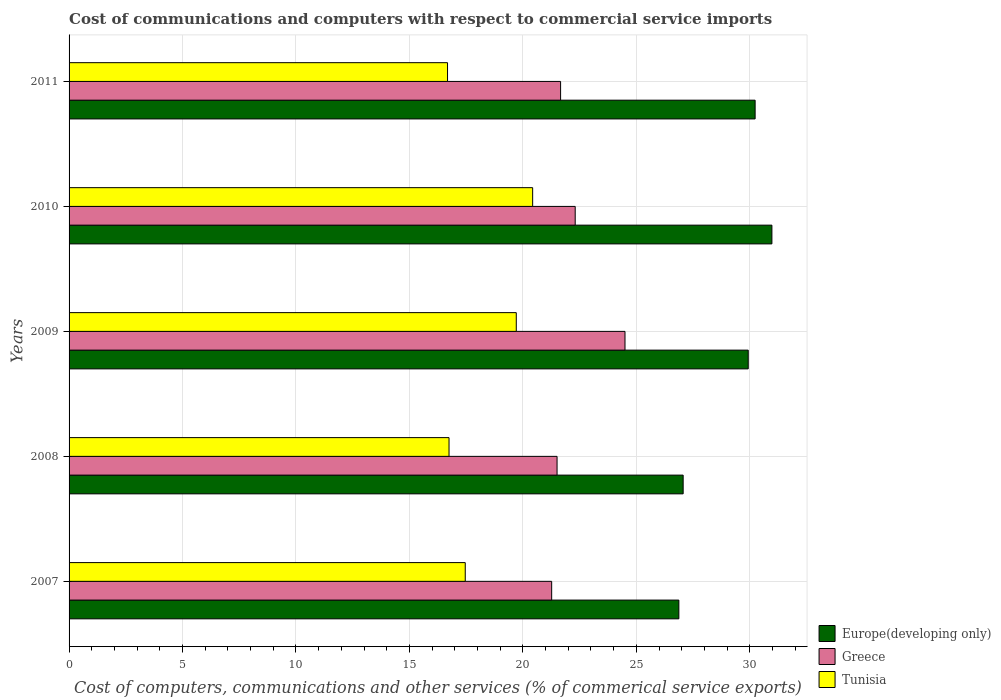How many different coloured bars are there?
Offer a terse response. 3. How many groups of bars are there?
Give a very brief answer. 5. How many bars are there on the 4th tick from the bottom?
Provide a succinct answer. 3. In how many cases, is the number of bars for a given year not equal to the number of legend labels?
Make the answer very short. 0. What is the cost of communications and computers in Tunisia in 2008?
Give a very brief answer. 16.75. Across all years, what is the maximum cost of communications and computers in Europe(developing only)?
Provide a short and direct response. 30.98. Across all years, what is the minimum cost of communications and computers in Tunisia?
Ensure brevity in your answer.  16.68. In which year was the cost of communications and computers in Europe(developing only) maximum?
Provide a succinct answer. 2010. What is the total cost of communications and computers in Greece in the graph?
Offer a very short reply. 111.25. What is the difference between the cost of communications and computers in Europe(developing only) in 2007 and that in 2011?
Offer a very short reply. -3.36. What is the difference between the cost of communications and computers in Greece in 2010 and the cost of communications and computers in Europe(developing only) in 2007?
Ensure brevity in your answer.  -4.57. What is the average cost of communications and computers in Europe(developing only) per year?
Your answer should be very brief. 29.02. In the year 2007, what is the difference between the cost of communications and computers in Greece and cost of communications and computers in Tunisia?
Your response must be concise. 3.81. In how many years, is the cost of communications and computers in Europe(developing only) greater than 3 %?
Offer a terse response. 5. What is the ratio of the cost of communications and computers in Greece in 2008 to that in 2009?
Your response must be concise. 0.88. What is the difference between the highest and the second highest cost of communications and computers in Europe(developing only)?
Keep it short and to the point. 0.74. What is the difference between the highest and the lowest cost of communications and computers in Tunisia?
Keep it short and to the point. 3.75. What does the 3rd bar from the bottom in 2007 represents?
Offer a very short reply. Tunisia. Are all the bars in the graph horizontal?
Provide a succinct answer. Yes. Are the values on the major ticks of X-axis written in scientific E-notation?
Keep it short and to the point. No. Does the graph contain any zero values?
Give a very brief answer. No. Does the graph contain grids?
Provide a succinct answer. Yes. Where does the legend appear in the graph?
Provide a short and direct response. Bottom right. How many legend labels are there?
Your answer should be very brief. 3. What is the title of the graph?
Your answer should be compact. Cost of communications and computers with respect to commercial service imports. What is the label or title of the X-axis?
Provide a short and direct response. Cost of computers, communications and other services (% of commerical service exports). What is the label or title of the Y-axis?
Provide a succinct answer. Years. What is the Cost of computers, communications and other services (% of commerical service exports) of Europe(developing only) in 2007?
Your answer should be compact. 26.88. What is the Cost of computers, communications and other services (% of commerical service exports) of Greece in 2007?
Offer a very short reply. 21.27. What is the Cost of computers, communications and other services (% of commerical service exports) in Tunisia in 2007?
Provide a succinct answer. 17.46. What is the Cost of computers, communications and other services (% of commerical service exports) of Europe(developing only) in 2008?
Your answer should be very brief. 27.07. What is the Cost of computers, communications and other services (% of commerical service exports) in Greece in 2008?
Give a very brief answer. 21.51. What is the Cost of computers, communications and other services (% of commerical service exports) in Tunisia in 2008?
Your answer should be very brief. 16.75. What is the Cost of computers, communications and other services (% of commerical service exports) of Europe(developing only) in 2009?
Keep it short and to the point. 29.93. What is the Cost of computers, communications and other services (% of commerical service exports) in Greece in 2009?
Make the answer very short. 24.5. What is the Cost of computers, communications and other services (% of commerical service exports) in Tunisia in 2009?
Your answer should be very brief. 19.71. What is the Cost of computers, communications and other services (% of commerical service exports) in Europe(developing only) in 2010?
Make the answer very short. 30.98. What is the Cost of computers, communications and other services (% of commerical service exports) in Greece in 2010?
Your answer should be very brief. 22.31. What is the Cost of computers, communications and other services (% of commerical service exports) of Tunisia in 2010?
Provide a short and direct response. 20.43. What is the Cost of computers, communications and other services (% of commerical service exports) in Europe(developing only) in 2011?
Your answer should be compact. 30.24. What is the Cost of computers, communications and other services (% of commerical service exports) in Greece in 2011?
Your answer should be very brief. 21.66. What is the Cost of computers, communications and other services (% of commerical service exports) in Tunisia in 2011?
Your answer should be very brief. 16.68. Across all years, what is the maximum Cost of computers, communications and other services (% of commerical service exports) of Europe(developing only)?
Offer a very short reply. 30.98. Across all years, what is the maximum Cost of computers, communications and other services (% of commerical service exports) in Greece?
Ensure brevity in your answer.  24.5. Across all years, what is the maximum Cost of computers, communications and other services (% of commerical service exports) of Tunisia?
Make the answer very short. 20.43. Across all years, what is the minimum Cost of computers, communications and other services (% of commerical service exports) in Europe(developing only)?
Ensure brevity in your answer.  26.88. Across all years, what is the minimum Cost of computers, communications and other services (% of commerical service exports) of Greece?
Offer a terse response. 21.27. Across all years, what is the minimum Cost of computers, communications and other services (% of commerical service exports) in Tunisia?
Keep it short and to the point. 16.68. What is the total Cost of computers, communications and other services (% of commerical service exports) of Europe(developing only) in the graph?
Provide a succinct answer. 145.09. What is the total Cost of computers, communications and other services (% of commerical service exports) in Greece in the graph?
Your response must be concise. 111.25. What is the total Cost of computers, communications and other services (% of commerical service exports) of Tunisia in the graph?
Your answer should be compact. 91.03. What is the difference between the Cost of computers, communications and other services (% of commerical service exports) of Europe(developing only) in 2007 and that in 2008?
Provide a short and direct response. -0.19. What is the difference between the Cost of computers, communications and other services (% of commerical service exports) in Greece in 2007 and that in 2008?
Make the answer very short. -0.24. What is the difference between the Cost of computers, communications and other services (% of commerical service exports) of Tunisia in 2007 and that in 2008?
Your response must be concise. 0.71. What is the difference between the Cost of computers, communications and other services (% of commerical service exports) in Europe(developing only) in 2007 and that in 2009?
Provide a short and direct response. -3.06. What is the difference between the Cost of computers, communications and other services (% of commerical service exports) in Greece in 2007 and that in 2009?
Your answer should be very brief. -3.23. What is the difference between the Cost of computers, communications and other services (% of commerical service exports) of Tunisia in 2007 and that in 2009?
Keep it short and to the point. -2.25. What is the difference between the Cost of computers, communications and other services (% of commerical service exports) in Europe(developing only) in 2007 and that in 2010?
Provide a succinct answer. -4.1. What is the difference between the Cost of computers, communications and other services (% of commerical service exports) of Greece in 2007 and that in 2010?
Provide a succinct answer. -1.04. What is the difference between the Cost of computers, communications and other services (% of commerical service exports) of Tunisia in 2007 and that in 2010?
Keep it short and to the point. -2.97. What is the difference between the Cost of computers, communications and other services (% of commerical service exports) in Europe(developing only) in 2007 and that in 2011?
Provide a succinct answer. -3.36. What is the difference between the Cost of computers, communications and other services (% of commerical service exports) of Greece in 2007 and that in 2011?
Your answer should be very brief. -0.39. What is the difference between the Cost of computers, communications and other services (% of commerical service exports) of Tunisia in 2007 and that in 2011?
Offer a very short reply. 0.78. What is the difference between the Cost of computers, communications and other services (% of commerical service exports) of Europe(developing only) in 2008 and that in 2009?
Your answer should be very brief. -2.87. What is the difference between the Cost of computers, communications and other services (% of commerical service exports) in Greece in 2008 and that in 2009?
Your answer should be very brief. -2.99. What is the difference between the Cost of computers, communications and other services (% of commerical service exports) of Tunisia in 2008 and that in 2009?
Your response must be concise. -2.96. What is the difference between the Cost of computers, communications and other services (% of commerical service exports) of Europe(developing only) in 2008 and that in 2010?
Give a very brief answer. -3.91. What is the difference between the Cost of computers, communications and other services (% of commerical service exports) in Greece in 2008 and that in 2010?
Ensure brevity in your answer.  -0.8. What is the difference between the Cost of computers, communications and other services (% of commerical service exports) of Tunisia in 2008 and that in 2010?
Provide a succinct answer. -3.69. What is the difference between the Cost of computers, communications and other services (% of commerical service exports) in Europe(developing only) in 2008 and that in 2011?
Your response must be concise. -3.17. What is the difference between the Cost of computers, communications and other services (% of commerical service exports) of Greece in 2008 and that in 2011?
Your answer should be compact. -0.16. What is the difference between the Cost of computers, communications and other services (% of commerical service exports) in Tunisia in 2008 and that in 2011?
Provide a succinct answer. 0.07. What is the difference between the Cost of computers, communications and other services (% of commerical service exports) of Europe(developing only) in 2009 and that in 2010?
Offer a very short reply. -1.04. What is the difference between the Cost of computers, communications and other services (% of commerical service exports) in Greece in 2009 and that in 2010?
Your answer should be compact. 2.19. What is the difference between the Cost of computers, communications and other services (% of commerical service exports) in Tunisia in 2009 and that in 2010?
Your response must be concise. -0.72. What is the difference between the Cost of computers, communications and other services (% of commerical service exports) in Europe(developing only) in 2009 and that in 2011?
Offer a very short reply. -0.3. What is the difference between the Cost of computers, communications and other services (% of commerical service exports) of Greece in 2009 and that in 2011?
Ensure brevity in your answer.  2.84. What is the difference between the Cost of computers, communications and other services (% of commerical service exports) of Tunisia in 2009 and that in 2011?
Offer a terse response. 3.03. What is the difference between the Cost of computers, communications and other services (% of commerical service exports) in Europe(developing only) in 2010 and that in 2011?
Keep it short and to the point. 0.74. What is the difference between the Cost of computers, communications and other services (% of commerical service exports) of Greece in 2010 and that in 2011?
Provide a short and direct response. 0.64. What is the difference between the Cost of computers, communications and other services (% of commerical service exports) of Tunisia in 2010 and that in 2011?
Keep it short and to the point. 3.75. What is the difference between the Cost of computers, communications and other services (% of commerical service exports) of Europe(developing only) in 2007 and the Cost of computers, communications and other services (% of commerical service exports) of Greece in 2008?
Ensure brevity in your answer.  5.37. What is the difference between the Cost of computers, communications and other services (% of commerical service exports) of Europe(developing only) in 2007 and the Cost of computers, communications and other services (% of commerical service exports) of Tunisia in 2008?
Make the answer very short. 10.13. What is the difference between the Cost of computers, communications and other services (% of commerical service exports) in Greece in 2007 and the Cost of computers, communications and other services (% of commerical service exports) in Tunisia in 2008?
Offer a very short reply. 4.52. What is the difference between the Cost of computers, communications and other services (% of commerical service exports) in Europe(developing only) in 2007 and the Cost of computers, communications and other services (% of commerical service exports) in Greece in 2009?
Your response must be concise. 2.37. What is the difference between the Cost of computers, communications and other services (% of commerical service exports) in Europe(developing only) in 2007 and the Cost of computers, communications and other services (% of commerical service exports) in Tunisia in 2009?
Your answer should be compact. 7.17. What is the difference between the Cost of computers, communications and other services (% of commerical service exports) in Greece in 2007 and the Cost of computers, communications and other services (% of commerical service exports) in Tunisia in 2009?
Give a very brief answer. 1.56. What is the difference between the Cost of computers, communications and other services (% of commerical service exports) of Europe(developing only) in 2007 and the Cost of computers, communications and other services (% of commerical service exports) of Greece in 2010?
Offer a terse response. 4.57. What is the difference between the Cost of computers, communications and other services (% of commerical service exports) in Europe(developing only) in 2007 and the Cost of computers, communications and other services (% of commerical service exports) in Tunisia in 2010?
Give a very brief answer. 6.44. What is the difference between the Cost of computers, communications and other services (% of commerical service exports) of Greece in 2007 and the Cost of computers, communications and other services (% of commerical service exports) of Tunisia in 2010?
Keep it short and to the point. 0.84. What is the difference between the Cost of computers, communications and other services (% of commerical service exports) of Europe(developing only) in 2007 and the Cost of computers, communications and other services (% of commerical service exports) of Greece in 2011?
Your answer should be compact. 5.21. What is the difference between the Cost of computers, communications and other services (% of commerical service exports) of Europe(developing only) in 2007 and the Cost of computers, communications and other services (% of commerical service exports) of Tunisia in 2011?
Your answer should be compact. 10.2. What is the difference between the Cost of computers, communications and other services (% of commerical service exports) of Greece in 2007 and the Cost of computers, communications and other services (% of commerical service exports) of Tunisia in 2011?
Ensure brevity in your answer.  4.59. What is the difference between the Cost of computers, communications and other services (% of commerical service exports) in Europe(developing only) in 2008 and the Cost of computers, communications and other services (% of commerical service exports) in Greece in 2009?
Ensure brevity in your answer.  2.56. What is the difference between the Cost of computers, communications and other services (% of commerical service exports) in Europe(developing only) in 2008 and the Cost of computers, communications and other services (% of commerical service exports) in Tunisia in 2009?
Your answer should be compact. 7.36. What is the difference between the Cost of computers, communications and other services (% of commerical service exports) in Greece in 2008 and the Cost of computers, communications and other services (% of commerical service exports) in Tunisia in 2009?
Offer a very short reply. 1.8. What is the difference between the Cost of computers, communications and other services (% of commerical service exports) of Europe(developing only) in 2008 and the Cost of computers, communications and other services (% of commerical service exports) of Greece in 2010?
Keep it short and to the point. 4.76. What is the difference between the Cost of computers, communications and other services (% of commerical service exports) in Europe(developing only) in 2008 and the Cost of computers, communications and other services (% of commerical service exports) in Tunisia in 2010?
Provide a succinct answer. 6.63. What is the difference between the Cost of computers, communications and other services (% of commerical service exports) in Greece in 2008 and the Cost of computers, communications and other services (% of commerical service exports) in Tunisia in 2010?
Provide a succinct answer. 1.08. What is the difference between the Cost of computers, communications and other services (% of commerical service exports) of Europe(developing only) in 2008 and the Cost of computers, communications and other services (% of commerical service exports) of Greece in 2011?
Provide a short and direct response. 5.4. What is the difference between the Cost of computers, communications and other services (% of commerical service exports) of Europe(developing only) in 2008 and the Cost of computers, communications and other services (% of commerical service exports) of Tunisia in 2011?
Offer a very short reply. 10.38. What is the difference between the Cost of computers, communications and other services (% of commerical service exports) of Greece in 2008 and the Cost of computers, communications and other services (% of commerical service exports) of Tunisia in 2011?
Your response must be concise. 4.83. What is the difference between the Cost of computers, communications and other services (% of commerical service exports) of Europe(developing only) in 2009 and the Cost of computers, communications and other services (% of commerical service exports) of Greece in 2010?
Keep it short and to the point. 7.63. What is the difference between the Cost of computers, communications and other services (% of commerical service exports) in Europe(developing only) in 2009 and the Cost of computers, communications and other services (% of commerical service exports) in Tunisia in 2010?
Your answer should be very brief. 9.5. What is the difference between the Cost of computers, communications and other services (% of commerical service exports) in Greece in 2009 and the Cost of computers, communications and other services (% of commerical service exports) in Tunisia in 2010?
Provide a succinct answer. 4.07. What is the difference between the Cost of computers, communications and other services (% of commerical service exports) in Europe(developing only) in 2009 and the Cost of computers, communications and other services (% of commerical service exports) in Greece in 2011?
Give a very brief answer. 8.27. What is the difference between the Cost of computers, communications and other services (% of commerical service exports) of Europe(developing only) in 2009 and the Cost of computers, communications and other services (% of commerical service exports) of Tunisia in 2011?
Make the answer very short. 13.25. What is the difference between the Cost of computers, communications and other services (% of commerical service exports) of Greece in 2009 and the Cost of computers, communications and other services (% of commerical service exports) of Tunisia in 2011?
Keep it short and to the point. 7.82. What is the difference between the Cost of computers, communications and other services (% of commerical service exports) in Europe(developing only) in 2010 and the Cost of computers, communications and other services (% of commerical service exports) in Greece in 2011?
Ensure brevity in your answer.  9.31. What is the difference between the Cost of computers, communications and other services (% of commerical service exports) of Europe(developing only) in 2010 and the Cost of computers, communications and other services (% of commerical service exports) of Tunisia in 2011?
Provide a short and direct response. 14.3. What is the difference between the Cost of computers, communications and other services (% of commerical service exports) of Greece in 2010 and the Cost of computers, communications and other services (% of commerical service exports) of Tunisia in 2011?
Your answer should be compact. 5.63. What is the average Cost of computers, communications and other services (% of commerical service exports) of Europe(developing only) per year?
Offer a terse response. 29.02. What is the average Cost of computers, communications and other services (% of commerical service exports) in Greece per year?
Make the answer very short. 22.25. What is the average Cost of computers, communications and other services (% of commerical service exports) of Tunisia per year?
Offer a terse response. 18.21. In the year 2007, what is the difference between the Cost of computers, communications and other services (% of commerical service exports) in Europe(developing only) and Cost of computers, communications and other services (% of commerical service exports) in Greece?
Give a very brief answer. 5.61. In the year 2007, what is the difference between the Cost of computers, communications and other services (% of commerical service exports) in Europe(developing only) and Cost of computers, communications and other services (% of commerical service exports) in Tunisia?
Your answer should be very brief. 9.41. In the year 2007, what is the difference between the Cost of computers, communications and other services (% of commerical service exports) of Greece and Cost of computers, communications and other services (% of commerical service exports) of Tunisia?
Offer a very short reply. 3.81. In the year 2008, what is the difference between the Cost of computers, communications and other services (% of commerical service exports) of Europe(developing only) and Cost of computers, communications and other services (% of commerical service exports) of Greece?
Your response must be concise. 5.56. In the year 2008, what is the difference between the Cost of computers, communications and other services (% of commerical service exports) of Europe(developing only) and Cost of computers, communications and other services (% of commerical service exports) of Tunisia?
Provide a succinct answer. 10.32. In the year 2008, what is the difference between the Cost of computers, communications and other services (% of commerical service exports) in Greece and Cost of computers, communications and other services (% of commerical service exports) in Tunisia?
Your answer should be compact. 4.76. In the year 2009, what is the difference between the Cost of computers, communications and other services (% of commerical service exports) in Europe(developing only) and Cost of computers, communications and other services (% of commerical service exports) in Greece?
Keep it short and to the point. 5.43. In the year 2009, what is the difference between the Cost of computers, communications and other services (% of commerical service exports) of Europe(developing only) and Cost of computers, communications and other services (% of commerical service exports) of Tunisia?
Your response must be concise. 10.22. In the year 2009, what is the difference between the Cost of computers, communications and other services (% of commerical service exports) in Greece and Cost of computers, communications and other services (% of commerical service exports) in Tunisia?
Offer a very short reply. 4.79. In the year 2010, what is the difference between the Cost of computers, communications and other services (% of commerical service exports) in Europe(developing only) and Cost of computers, communications and other services (% of commerical service exports) in Greece?
Your answer should be very brief. 8.67. In the year 2010, what is the difference between the Cost of computers, communications and other services (% of commerical service exports) in Europe(developing only) and Cost of computers, communications and other services (% of commerical service exports) in Tunisia?
Ensure brevity in your answer.  10.54. In the year 2010, what is the difference between the Cost of computers, communications and other services (% of commerical service exports) in Greece and Cost of computers, communications and other services (% of commerical service exports) in Tunisia?
Offer a very short reply. 1.88. In the year 2011, what is the difference between the Cost of computers, communications and other services (% of commerical service exports) of Europe(developing only) and Cost of computers, communications and other services (% of commerical service exports) of Greece?
Keep it short and to the point. 8.57. In the year 2011, what is the difference between the Cost of computers, communications and other services (% of commerical service exports) in Europe(developing only) and Cost of computers, communications and other services (% of commerical service exports) in Tunisia?
Keep it short and to the point. 13.56. In the year 2011, what is the difference between the Cost of computers, communications and other services (% of commerical service exports) in Greece and Cost of computers, communications and other services (% of commerical service exports) in Tunisia?
Your answer should be compact. 4.98. What is the ratio of the Cost of computers, communications and other services (% of commerical service exports) of Europe(developing only) in 2007 to that in 2008?
Keep it short and to the point. 0.99. What is the ratio of the Cost of computers, communications and other services (% of commerical service exports) of Tunisia in 2007 to that in 2008?
Make the answer very short. 1.04. What is the ratio of the Cost of computers, communications and other services (% of commerical service exports) of Europe(developing only) in 2007 to that in 2009?
Your answer should be very brief. 0.9. What is the ratio of the Cost of computers, communications and other services (% of commerical service exports) in Greece in 2007 to that in 2009?
Offer a terse response. 0.87. What is the ratio of the Cost of computers, communications and other services (% of commerical service exports) of Tunisia in 2007 to that in 2009?
Your response must be concise. 0.89. What is the ratio of the Cost of computers, communications and other services (% of commerical service exports) in Europe(developing only) in 2007 to that in 2010?
Ensure brevity in your answer.  0.87. What is the ratio of the Cost of computers, communications and other services (% of commerical service exports) in Greece in 2007 to that in 2010?
Keep it short and to the point. 0.95. What is the ratio of the Cost of computers, communications and other services (% of commerical service exports) of Tunisia in 2007 to that in 2010?
Your answer should be compact. 0.85. What is the ratio of the Cost of computers, communications and other services (% of commerical service exports) in Europe(developing only) in 2007 to that in 2011?
Offer a very short reply. 0.89. What is the ratio of the Cost of computers, communications and other services (% of commerical service exports) in Greece in 2007 to that in 2011?
Make the answer very short. 0.98. What is the ratio of the Cost of computers, communications and other services (% of commerical service exports) in Tunisia in 2007 to that in 2011?
Your answer should be compact. 1.05. What is the ratio of the Cost of computers, communications and other services (% of commerical service exports) in Europe(developing only) in 2008 to that in 2009?
Give a very brief answer. 0.9. What is the ratio of the Cost of computers, communications and other services (% of commerical service exports) in Greece in 2008 to that in 2009?
Your response must be concise. 0.88. What is the ratio of the Cost of computers, communications and other services (% of commerical service exports) of Tunisia in 2008 to that in 2009?
Ensure brevity in your answer.  0.85. What is the ratio of the Cost of computers, communications and other services (% of commerical service exports) in Europe(developing only) in 2008 to that in 2010?
Your answer should be compact. 0.87. What is the ratio of the Cost of computers, communications and other services (% of commerical service exports) in Greece in 2008 to that in 2010?
Offer a terse response. 0.96. What is the ratio of the Cost of computers, communications and other services (% of commerical service exports) in Tunisia in 2008 to that in 2010?
Ensure brevity in your answer.  0.82. What is the ratio of the Cost of computers, communications and other services (% of commerical service exports) in Europe(developing only) in 2008 to that in 2011?
Ensure brevity in your answer.  0.9. What is the ratio of the Cost of computers, communications and other services (% of commerical service exports) in Tunisia in 2008 to that in 2011?
Offer a very short reply. 1. What is the ratio of the Cost of computers, communications and other services (% of commerical service exports) of Europe(developing only) in 2009 to that in 2010?
Provide a succinct answer. 0.97. What is the ratio of the Cost of computers, communications and other services (% of commerical service exports) in Greece in 2009 to that in 2010?
Give a very brief answer. 1.1. What is the ratio of the Cost of computers, communications and other services (% of commerical service exports) in Tunisia in 2009 to that in 2010?
Your response must be concise. 0.96. What is the ratio of the Cost of computers, communications and other services (% of commerical service exports) in Europe(developing only) in 2009 to that in 2011?
Provide a succinct answer. 0.99. What is the ratio of the Cost of computers, communications and other services (% of commerical service exports) of Greece in 2009 to that in 2011?
Offer a very short reply. 1.13. What is the ratio of the Cost of computers, communications and other services (% of commerical service exports) of Tunisia in 2009 to that in 2011?
Offer a terse response. 1.18. What is the ratio of the Cost of computers, communications and other services (% of commerical service exports) of Europe(developing only) in 2010 to that in 2011?
Offer a very short reply. 1.02. What is the ratio of the Cost of computers, communications and other services (% of commerical service exports) of Greece in 2010 to that in 2011?
Your answer should be very brief. 1.03. What is the ratio of the Cost of computers, communications and other services (% of commerical service exports) of Tunisia in 2010 to that in 2011?
Keep it short and to the point. 1.22. What is the difference between the highest and the second highest Cost of computers, communications and other services (% of commerical service exports) in Europe(developing only)?
Ensure brevity in your answer.  0.74. What is the difference between the highest and the second highest Cost of computers, communications and other services (% of commerical service exports) in Greece?
Ensure brevity in your answer.  2.19. What is the difference between the highest and the second highest Cost of computers, communications and other services (% of commerical service exports) of Tunisia?
Your answer should be very brief. 0.72. What is the difference between the highest and the lowest Cost of computers, communications and other services (% of commerical service exports) in Europe(developing only)?
Give a very brief answer. 4.1. What is the difference between the highest and the lowest Cost of computers, communications and other services (% of commerical service exports) in Greece?
Give a very brief answer. 3.23. What is the difference between the highest and the lowest Cost of computers, communications and other services (% of commerical service exports) of Tunisia?
Offer a very short reply. 3.75. 